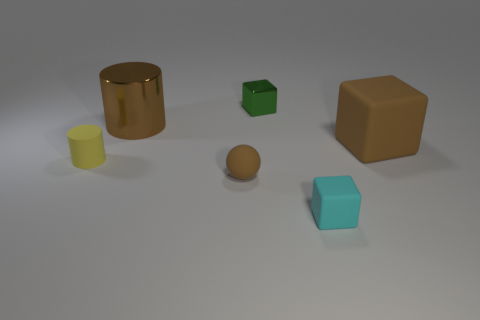There is a thing that is in front of the brown rubber sphere; how big is it?
Provide a succinct answer. Small. What number of other things are there of the same material as the cyan cube
Make the answer very short. 3. Is there a small green metallic cube to the right of the tiny block in front of the small brown object?
Your answer should be compact. No. Is there any other thing that has the same shape as the yellow rubber thing?
Offer a terse response. Yes. What color is the other small thing that is the same shape as the cyan rubber thing?
Make the answer very short. Green. How big is the green metallic thing?
Make the answer very short. Small. Are there fewer things on the left side of the brown cylinder than big brown cylinders?
Your answer should be compact. No. Are the yellow thing and the large object left of the tiny cyan rubber block made of the same material?
Offer a terse response. No. There is a big brown thing that is behind the brown object right of the small green object; are there any tiny green metallic blocks that are in front of it?
Offer a very short reply. No. Is there any other thing that is the same size as the brown metallic object?
Your answer should be very brief. Yes. 